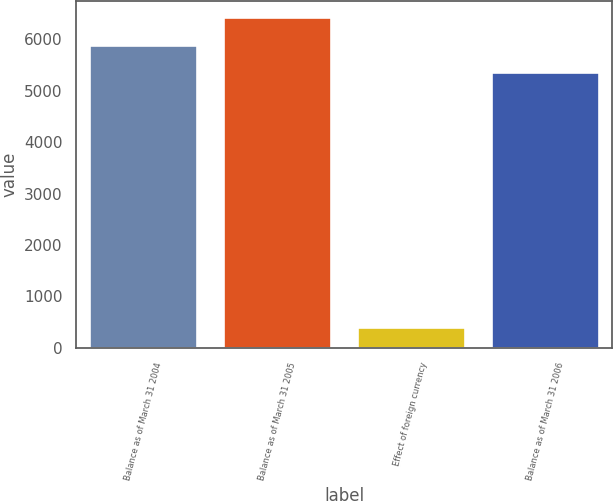<chart> <loc_0><loc_0><loc_500><loc_500><bar_chart><fcel>Balance as of March 31 2004<fcel>Balance as of March 31 2005<fcel>Effect of foreign currency<fcel>Balance as of March 31 2006<nl><fcel>5887.2<fcel>6422.4<fcel>410<fcel>5352<nl></chart> 